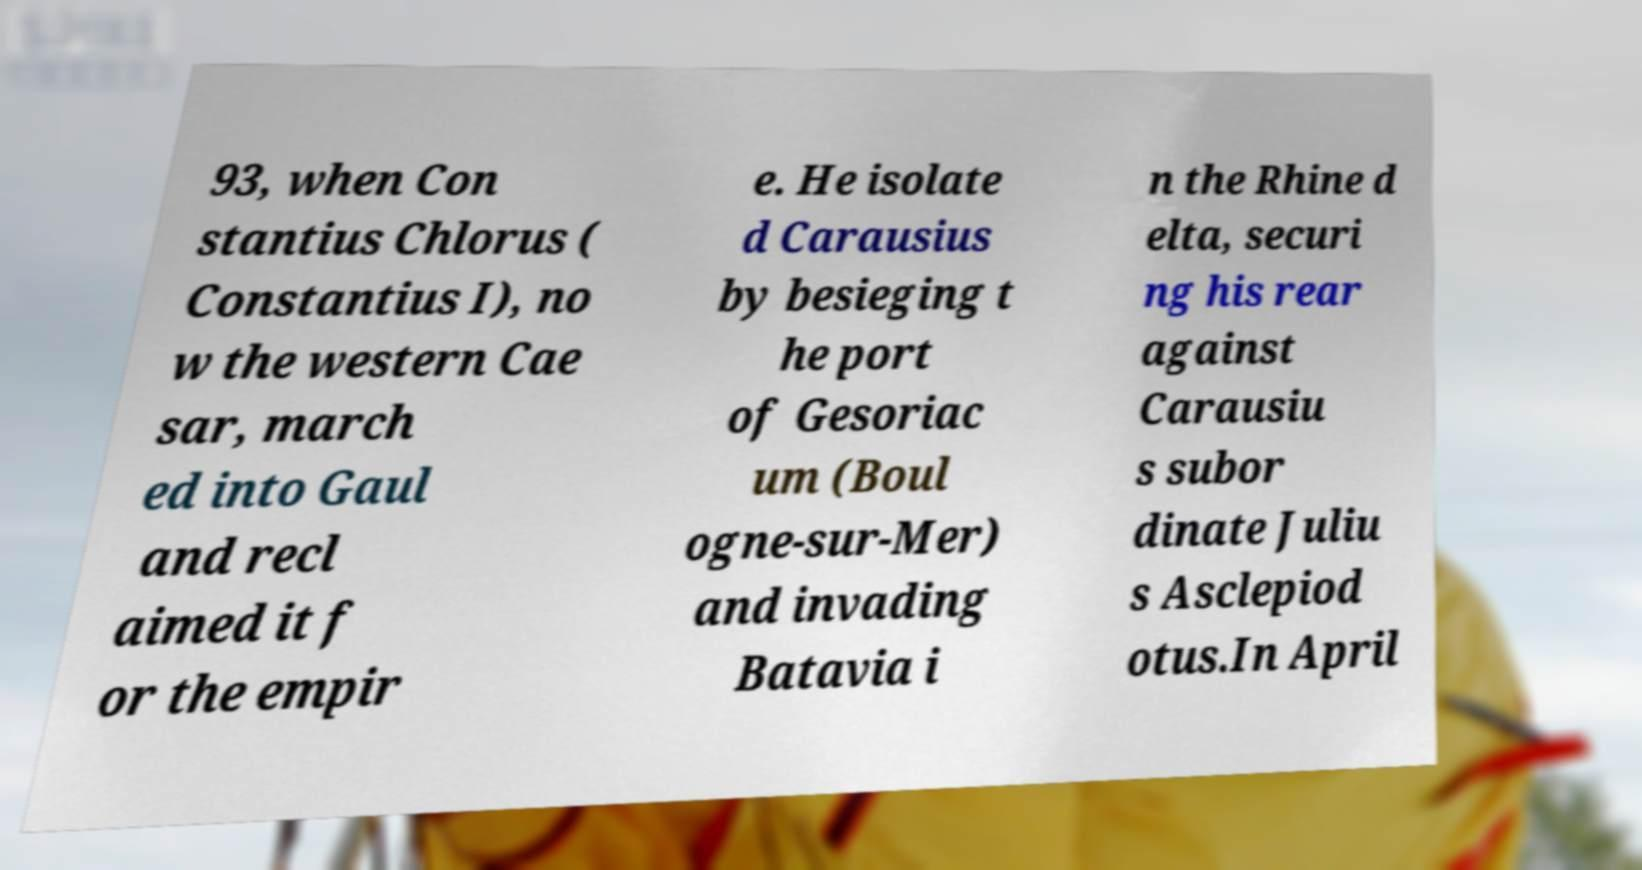Can you read and provide the text displayed in the image?This photo seems to have some interesting text. Can you extract and type it out for me? 93, when Con stantius Chlorus ( Constantius I), no w the western Cae sar, march ed into Gaul and recl aimed it f or the empir e. He isolate d Carausius by besieging t he port of Gesoriac um (Boul ogne-sur-Mer) and invading Batavia i n the Rhine d elta, securi ng his rear against Carausiu s subor dinate Juliu s Asclepiod otus.In April 